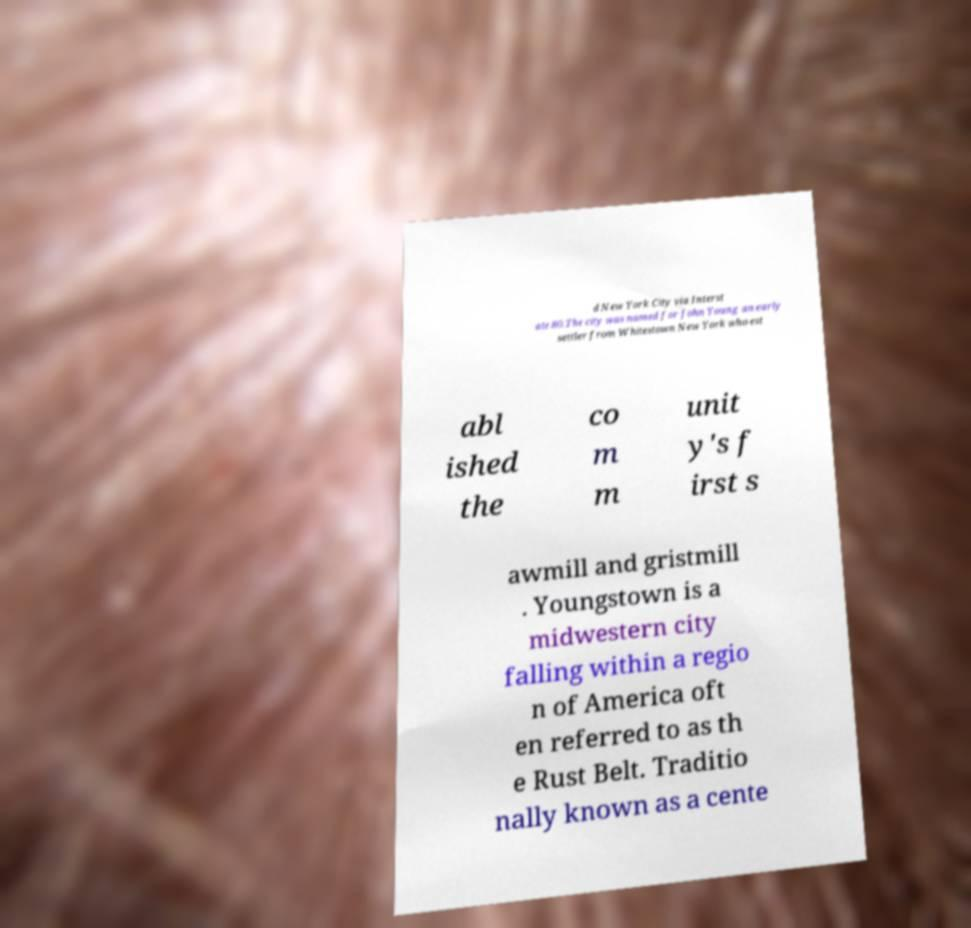Could you assist in decoding the text presented in this image and type it out clearly? d New York City via Interst ate 80.The city was named for John Young an early settler from Whitestown New York who est abl ished the co m m unit y's f irst s awmill and gristmill . Youngstown is a midwestern city falling within a regio n of America oft en referred to as th e Rust Belt. Traditio nally known as a cente 